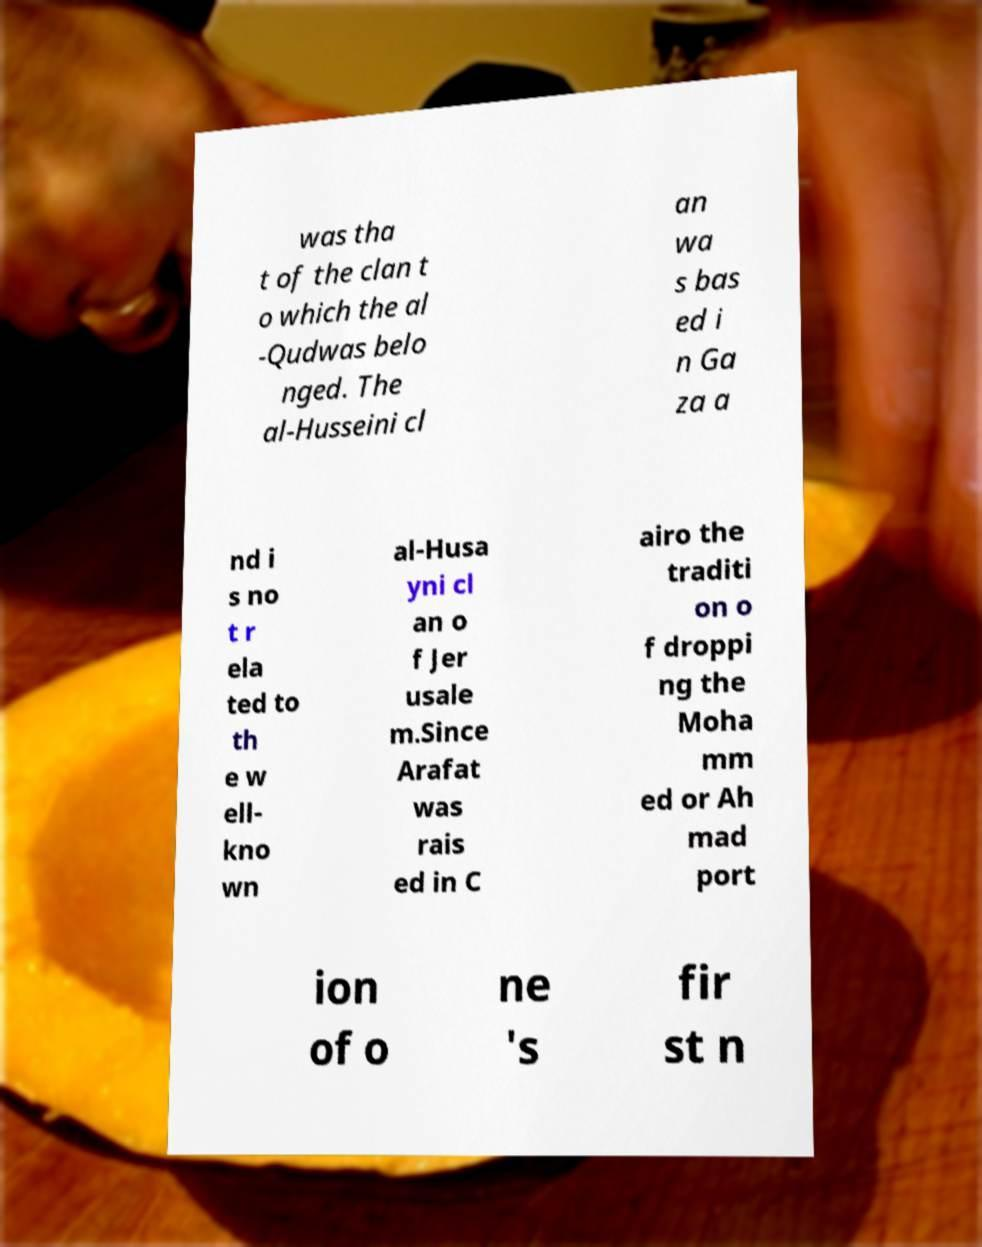There's text embedded in this image that I need extracted. Can you transcribe it verbatim? was tha t of the clan t o which the al -Qudwas belo nged. The al-Husseini cl an wa s bas ed i n Ga za a nd i s no t r ela ted to th e w ell- kno wn al-Husa yni cl an o f Jer usale m.Since Arafat was rais ed in C airo the traditi on o f droppi ng the Moha mm ed or Ah mad port ion of o ne 's fir st n 